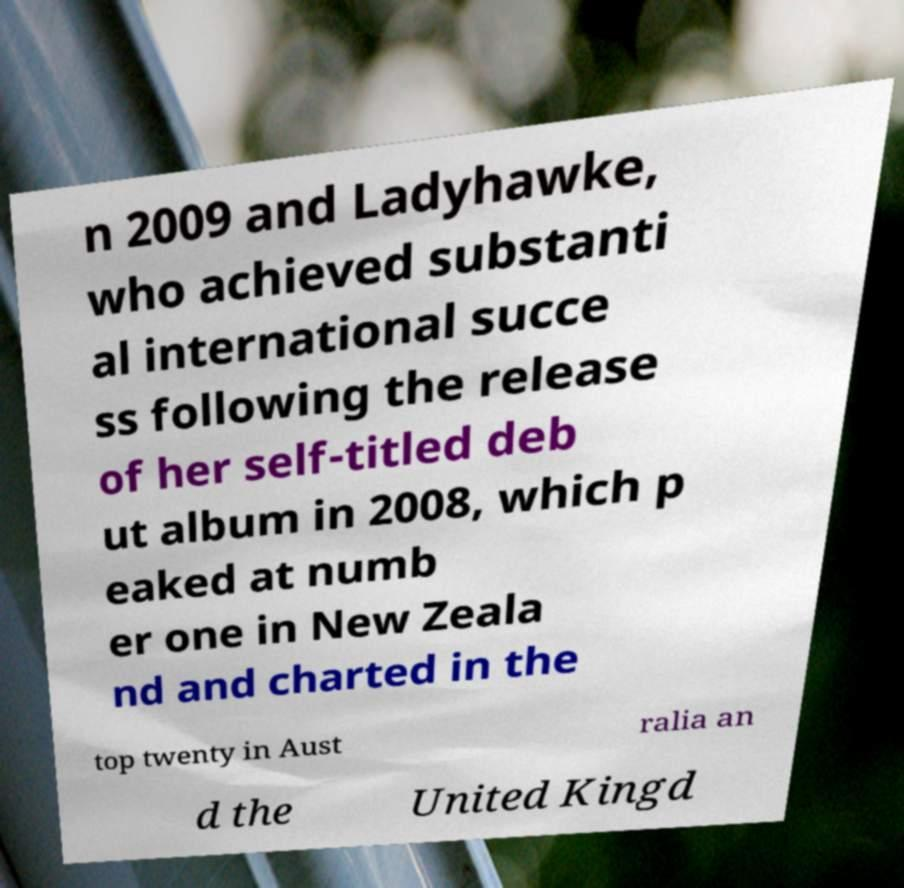What messages or text are displayed in this image? I need them in a readable, typed format. n 2009 and Ladyhawke, who achieved substanti al international succe ss following the release of her self-titled deb ut album in 2008, which p eaked at numb er one in New Zeala nd and charted in the top twenty in Aust ralia an d the United Kingd 